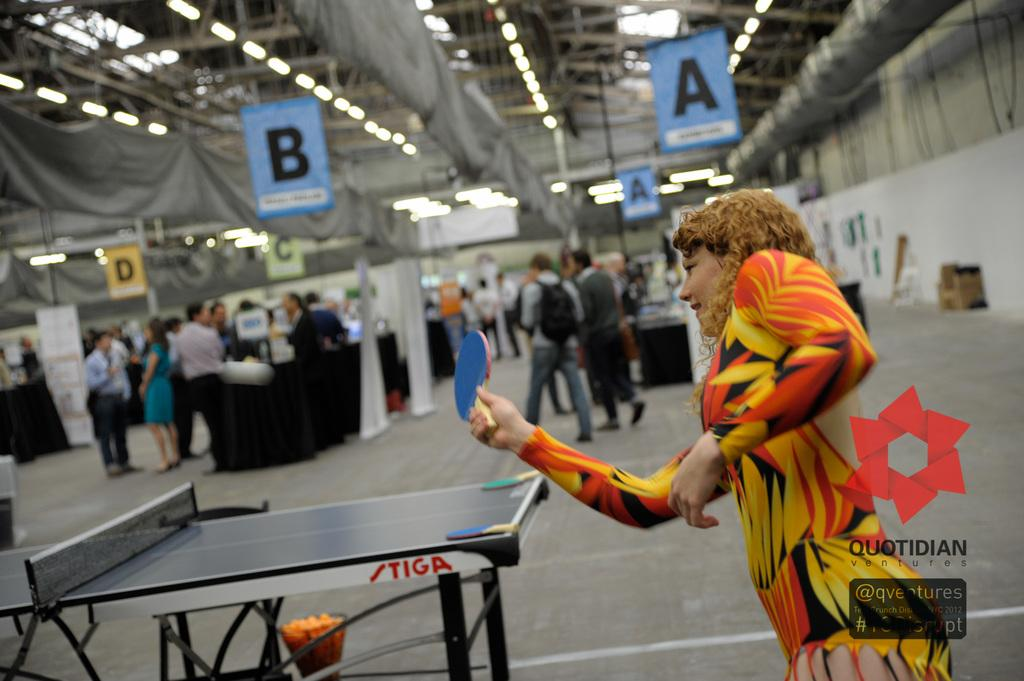What is the woman holding in the image? The woman is holding a bat. What can be seen on the table in the image? There are bats on the table. Are there any other objects or structures in the image? Yes, there is a table in the image. What are the people in the image doing? People are standing and walking in the image. How many hands does the ticket have in the image? There is no ticket present in the image, so it is not possible to determine how many hands it might have. 